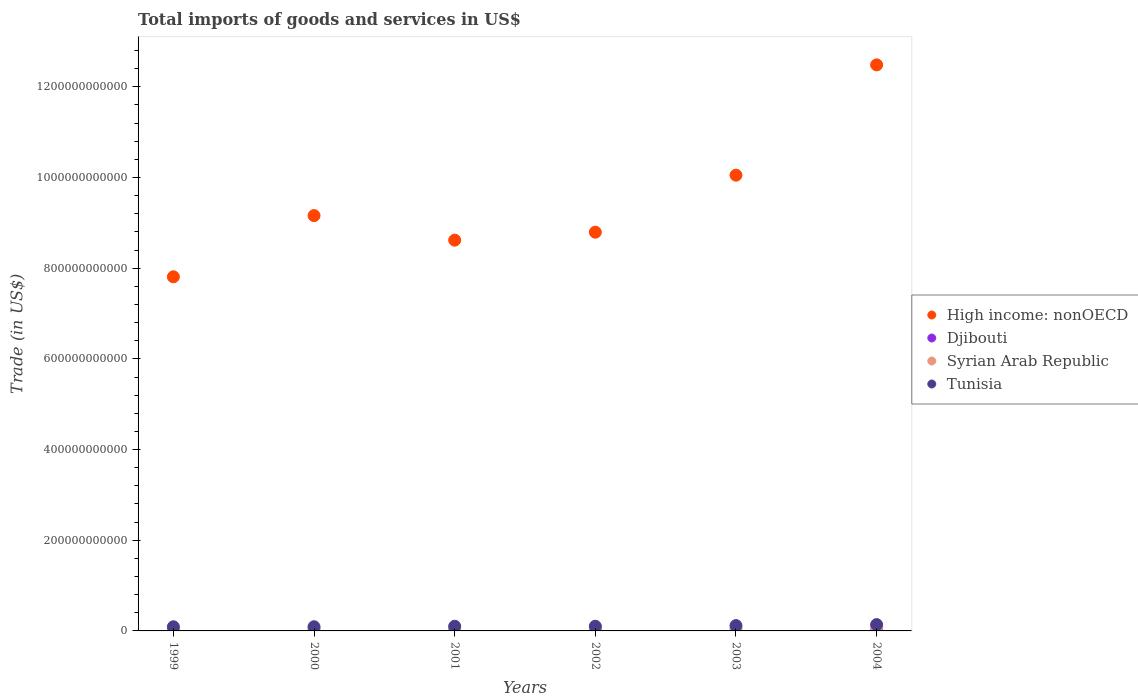What is the total imports of goods and services in High income: nonOECD in 2001?
Provide a short and direct response. 8.62e+11. Across all years, what is the maximum total imports of goods and services in Djibouti?
Keep it short and to the point. 3.61e+08. Across all years, what is the minimum total imports of goods and services in Syrian Arab Republic?
Your answer should be very brief. 5.08e+09. What is the total total imports of goods and services in Syrian Arab Republic in the graph?
Give a very brief answer. 3.96e+1. What is the difference between the total imports of goods and services in Djibouti in 1999 and that in 2002?
Keep it short and to the point. 6.13e+05. What is the difference between the total imports of goods and services in Syrian Arab Republic in 2002 and the total imports of goods and services in Tunisia in 2001?
Offer a very short reply. -3.72e+09. What is the average total imports of goods and services in Djibouti per year?
Give a very brief answer. 2.87e+08. In the year 2000, what is the difference between the total imports of goods and services in Syrian Arab Republic and total imports of goods and services in Tunisia?
Provide a succinct answer. -3.69e+09. In how many years, is the total imports of goods and services in Tunisia greater than 480000000000 US$?
Provide a succinct answer. 0. What is the ratio of the total imports of goods and services in High income: nonOECD in 1999 to that in 2000?
Your response must be concise. 0.85. Is the difference between the total imports of goods and services in Syrian Arab Republic in 2002 and 2004 greater than the difference between the total imports of goods and services in Tunisia in 2002 and 2004?
Your response must be concise. Yes. What is the difference between the highest and the second highest total imports of goods and services in Syrian Arab Republic?
Offer a very short reply. 3.40e+09. What is the difference between the highest and the lowest total imports of goods and services in High income: nonOECD?
Keep it short and to the point. 4.67e+11. Is the sum of the total imports of goods and services in Syrian Arab Republic in 2000 and 2003 greater than the maximum total imports of goods and services in High income: nonOECD across all years?
Provide a short and direct response. No. Is it the case that in every year, the sum of the total imports of goods and services in High income: nonOECD and total imports of goods and services in Djibouti  is greater than the sum of total imports of goods and services in Tunisia and total imports of goods and services in Syrian Arab Republic?
Provide a short and direct response. Yes. Is it the case that in every year, the sum of the total imports of goods and services in High income: nonOECD and total imports of goods and services in Tunisia  is greater than the total imports of goods and services in Syrian Arab Republic?
Give a very brief answer. Yes. Does the total imports of goods and services in Syrian Arab Republic monotonically increase over the years?
Provide a succinct answer. No. Is the total imports of goods and services in Tunisia strictly less than the total imports of goods and services in Djibouti over the years?
Provide a succinct answer. No. How many years are there in the graph?
Provide a short and direct response. 6. What is the difference between two consecutive major ticks on the Y-axis?
Ensure brevity in your answer.  2.00e+11. Does the graph contain any zero values?
Offer a very short reply. No. Does the graph contain grids?
Give a very brief answer. No. Where does the legend appear in the graph?
Offer a very short reply. Center right. How are the legend labels stacked?
Provide a succinct answer. Vertical. What is the title of the graph?
Your answer should be compact. Total imports of goods and services in US$. Does "Honduras" appear as one of the legend labels in the graph?
Your answer should be very brief. No. What is the label or title of the X-axis?
Your answer should be compact. Years. What is the label or title of the Y-axis?
Your answer should be compact. Trade (in US$). What is the Trade (in US$) in High income: nonOECD in 1999?
Make the answer very short. 7.81e+11. What is the Trade (in US$) of Djibouti in 1999?
Make the answer very short. 2.59e+08. What is the Trade (in US$) of Syrian Arab Republic in 1999?
Provide a short and direct response. 5.08e+09. What is the Trade (in US$) of Tunisia in 1999?
Make the answer very short. 9.16e+09. What is the Trade (in US$) in High income: nonOECD in 2000?
Ensure brevity in your answer.  9.16e+11. What is the Trade (in US$) in Djibouti in 2000?
Ensure brevity in your answer.  2.78e+08. What is the Trade (in US$) of Syrian Arab Republic in 2000?
Offer a terse response. 5.52e+09. What is the Trade (in US$) of Tunisia in 2000?
Give a very brief answer. 9.21e+09. What is the Trade (in US$) in High income: nonOECD in 2001?
Provide a succinct answer. 8.62e+11. What is the Trade (in US$) in Djibouti in 2001?
Ensure brevity in your answer.  2.62e+08. What is the Trade (in US$) in Syrian Arab Republic in 2001?
Ensure brevity in your answer.  6.17e+09. What is the Trade (in US$) in Tunisia in 2001?
Make the answer very short. 1.03e+1. What is the Trade (in US$) in High income: nonOECD in 2002?
Your answer should be very brief. 8.79e+11. What is the Trade (in US$) in Djibouti in 2002?
Make the answer very short. 2.59e+08. What is the Trade (in US$) in Syrian Arab Republic in 2002?
Offer a very short reply. 6.59e+09. What is the Trade (in US$) of Tunisia in 2002?
Your response must be concise. 1.03e+1. What is the Trade (in US$) in High income: nonOECD in 2003?
Your response must be concise. 1.01e+12. What is the Trade (in US$) in Djibouti in 2003?
Your answer should be compact. 3.05e+08. What is the Trade (in US$) in Syrian Arab Republic in 2003?
Offer a very short reply. 6.24e+09. What is the Trade (in US$) of Tunisia in 2003?
Provide a short and direct response. 1.18e+1. What is the Trade (in US$) in High income: nonOECD in 2004?
Make the answer very short. 1.25e+12. What is the Trade (in US$) of Djibouti in 2004?
Offer a very short reply. 3.61e+08. What is the Trade (in US$) in Syrian Arab Republic in 2004?
Provide a short and direct response. 9.99e+09. What is the Trade (in US$) of Tunisia in 2004?
Provide a short and direct response. 1.39e+1. Across all years, what is the maximum Trade (in US$) in High income: nonOECD?
Offer a very short reply. 1.25e+12. Across all years, what is the maximum Trade (in US$) in Djibouti?
Provide a short and direct response. 3.61e+08. Across all years, what is the maximum Trade (in US$) in Syrian Arab Republic?
Offer a terse response. 9.99e+09. Across all years, what is the maximum Trade (in US$) in Tunisia?
Make the answer very short. 1.39e+1. Across all years, what is the minimum Trade (in US$) of High income: nonOECD?
Provide a succinct answer. 7.81e+11. Across all years, what is the minimum Trade (in US$) of Djibouti?
Your answer should be very brief. 2.59e+08. Across all years, what is the minimum Trade (in US$) in Syrian Arab Republic?
Ensure brevity in your answer.  5.08e+09. Across all years, what is the minimum Trade (in US$) of Tunisia?
Offer a terse response. 9.16e+09. What is the total Trade (in US$) in High income: nonOECD in the graph?
Give a very brief answer. 5.69e+12. What is the total Trade (in US$) of Djibouti in the graph?
Provide a succinct answer. 1.72e+09. What is the total Trade (in US$) in Syrian Arab Republic in the graph?
Ensure brevity in your answer.  3.96e+1. What is the total Trade (in US$) in Tunisia in the graph?
Offer a terse response. 6.47e+1. What is the difference between the Trade (in US$) of High income: nonOECD in 1999 and that in 2000?
Give a very brief answer. -1.35e+11. What is the difference between the Trade (in US$) of Djibouti in 1999 and that in 2000?
Make the answer very short. -1.85e+07. What is the difference between the Trade (in US$) of Syrian Arab Republic in 1999 and that in 2000?
Provide a short and direct response. -4.45e+08. What is the difference between the Trade (in US$) in Tunisia in 1999 and that in 2000?
Your response must be concise. -5.35e+07. What is the difference between the Trade (in US$) of High income: nonOECD in 1999 and that in 2001?
Provide a succinct answer. -8.08e+1. What is the difference between the Trade (in US$) in Djibouti in 1999 and that in 2001?
Your answer should be very brief. -2.78e+06. What is the difference between the Trade (in US$) of Syrian Arab Republic in 1999 and that in 2001?
Give a very brief answer. -1.09e+09. What is the difference between the Trade (in US$) in Tunisia in 1999 and that in 2001?
Your answer should be compact. -1.15e+09. What is the difference between the Trade (in US$) of High income: nonOECD in 1999 and that in 2002?
Make the answer very short. -9.84e+1. What is the difference between the Trade (in US$) of Djibouti in 1999 and that in 2002?
Ensure brevity in your answer.  6.13e+05. What is the difference between the Trade (in US$) in Syrian Arab Republic in 1999 and that in 2002?
Give a very brief answer. -1.51e+09. What is the difference between the Trade (in US$) of Tunisia in 1999 and that in 2002?
Keep it short and to the point. -1.15e+09. What is the difference between the Trade (in US$) in High income: nonOECD in 1999 and that in 2003?
Keep it short and to the point. -2.24e+11. What is the difference between the Trade (in US$) of Djibouti in 1999 and that in 2003?
Keep it short and to the point. -4.60e+07. What is the difference between the Trade (in US$) in Syrian Arab Republic in 1999 and that in 2003?
Make the answer very short. -1.16e+09. What is the difference between the Trade (in US$) in Tunisia in 1999 and that in 2003?
Offer a terse response. -2.62e+09. What is the difference between the Trade (in US$) of High income: nonOECD in 1999 and that in 2004?
Give a very brief answer. -4.67e+11. What is the difference between the Trade (in US$) in Djibouti in 1999 and that in 2004?
Provide a short and direct response. -1.02e+08. What is the difference between the Trade (in US$) in Syrian Arab Republic in 1999 and that in 2004?
Your response must be concise. -4.91e+09. What is the difference between the Trade (in US$) in Tunisia in 1999 and that in 2004?
Your response must be concise. -4.79e+09. What is the difference between the Trade (in US$) in High income: nonOECD in 2000 and that in 2001?
Give a very brief answer. 5.42e+1. What is the difference between the Trade (in US$) in Djibouti in 2000 and that in 2001?
Your response must be concise. 1.57e+07. What is the difference between the Trade (in US$) in Syrian Arab Republic in 2000 and that in 2001?
Your answer should be very brief. -6.45e+08. What is the difference between the Trade (in US$) in Tunisia in 2000 and that in 2001?
Provide a succinct answer. -1.10e+09. What is the difference between the Trade (in US$) in High income: nonOECD in 2000 and that in 2002?
Keep it short and to the point. 3.66e+1. What is the difference between the Trade (in US$) in Djibouti in 2000 and that in 2002?
Offer a terse response. 1.91e+07. What is the difference between the Trade (in US$) of Syrian Arab Republic in 2000 and that in 2002?
Your answer should be very brief. -1.07e+09. What is the difference between the Trade (in US$) in Tunisia in 2000 and that in 2002?
Your response must be concise. -1.10e+09. What is the difference between the Trade (in US$) of High income: nonOECD in 2000 and that in 2003?
Offer a terse response. -8.91e+1. What is the difference between the Trade (in US$) in Djibouti in 2000 and that in 2003?
Give a very brief answer. -2.75e+07. What is the difference between the Trade (in US$) in Syrian Arab Republic in 2000 and that in 2003?
Provide a succinct answer. -7.12e+08. What is the difference between the Trade (in US$) of Tunisia in 2000 and that in 2003?
Provide a succinct answer. -2.57e+09. What is the difference between the Trade (in US$) in High income: nonOECD in 2000 and that in 2004?
Provide a short and direct response. -3.32e+11. What is the difference between the Trade (in US$) of Djibouti in 2000 and that in 2004?
Make the answer very short. -8.31e+07. What is the difference between the Trade (in US$) of Syrian Arab Republic in 2000 and that in 2004?
Ensure brevity in your answer.  -4.46e+09. What is the difference between the Trade (in US$) in Tunisia in 2000 and that in 2004?
Your answer should be very brief. -4.73e+09. What is the difference between the Trade (in US$) in High income: nonOECD in 2001 and that in 2002?
Offer a terse response. -1.76e+1. What is the difference between the Trade (in US$) in Djibouti in 2001 and that in 2002?
Keep it short and to the point. 3.39e+06. What is the difference between the Trade (in US$) of Syrian Arab Republic in 2001 and that in 2002?
Give a very brief answer. -4.23e+08. What is the difference between the Trade (in US$) of Tunisia in 2001 and that in 2002?
Provide a short and direct response. 1.11e+06. What is the difference between the Trade (in US$) of High income: nonOECD in 2001 and that in 2003?
Your answer should be very brief. -1.43e+11. What is the difference between the Trade (in US$) of Djibouti in 2001 and that in 2003?
Provide a succinct answer. -4.32e+07. What is the difference between the Trade (in US$) of Syrian Arab Republic in 2001 and that in 2003?
Ensure brevity in your answer.  -6.74e+07. What is the difference between the Trade (in US$) of Tunisia in 2001 and that in 2003?
Provide a succinct answer. -1.47e+09. What is the difference between the Trade (in US$) in High income: nonOECD in 2001 and that in 2004?
Offer a very short reply. -3.87e+11. What is the difference between the Trade (in US$) in Djibouti in 2001 and that in 2004?
Give a very brief answer. -9.88e+07. What is the difference between the Trade (in US$) in Syrian Arab Republic in 2001 and that in 2004?
Make the answer very short. -3.82e+09. What is the difference between the Trade (in US$) of Tunisia in 2001 and that in 2004?
Offer a very short reply. -3.63e+09. What is the difference between the Trade (in US$) in High income: nonOECD in 2002 and that in 2003?
Make the answer very short. -1.26e+11. What is the difference between the Trade (in US$) in Djibouti in 2002 and that in 2003?
Keep it short and to the point. -4.66e+07. What is the difference between the Trade (in US$) of Syrian Arab Republic in 2002 and that in 2003?
Provide a short and direct response. 3.56e+08. What is the difference between the Trade (in US$) of Tunisia in 2002 and that in 2003?
Your answer should be compact. -1.47e+09. What is the difference between the Trade (in US$) in High income: nonOECD in 2002 and that in 2004?
Your response must be concise. -3.69e+11. What is the difference between the Trade (in US$) of Djibouti in 2002 and that in 2004?
Provide a short and direct response. -1.02e+08. What is the difference between the Trade (in US$) of Syrian Arab Republic in 2002 and that in 2004?
Ensure brevity in your answer.  -3.40e+09. What is the difference between the Trade (in US$) of Tunisia in 2002 and that in 2004?
Offer a terse response. -3.64e+09. What is the difference between the Trade (in US$) in High income: nonOECD in 2003 and that in 2004?
Your answer should be very brief. -2.43e+11. What is the difference between the Trade (in US$) of Djibouti in 2003 and that in 2004?
Ensure brevity in your answer.  -5.56e+07. What is the difference between the Trade (in US$) in Syrian Arab Republic in 2003 and that in 2004?
Provide a succinct answer. -3.75e+09. What is the difference between the Trade (in US$) of Tunisia in 2003 and that in 2004?
Give a very brief answer. -2.17e+09. What is the difference between the Trade (in US$) of High income: nonOECD in 1999 and the Trade (in US$) of Djibouti in 2000?
Provide a succinct answer. 7.81e+11. What is the difference between the Trade (in US$) of High income: nonOECD in 1999 and the Trade (in US$) of Syrian Arab Republic in 2000?
Offer a very short reply. 7.75e+11. What is the difference between the Trade (in US$) in High income: nonOECD in 1999 and the Trade (in US$) in Tunisia in 2000?
Your answer should be very brief. 7.72e+11. What is the difference between the Trade (in US$) of Djibouti in 1999 and the Trade (in US$) of Syrian Arab Republic in 2000?
Offer a very short reply. -5.26e+09. What is the difference between the Trade (in US$) of Djibouti in 1999 and the Trade (in US$) of Tunisia in 2000?
Provide a succinct answer. -8.95e+09. What is the difference between the Trade (in US$) in Syrian Arab Republic in 1999 and the Trade (in US$) in Tunisia in 2000?
Your response must be concise. -4.14e+09. What is the difference between the Trade (in US$) of High income: nonOECD in 1999 and the Trade (in US$) of Djibouti in 2001?
Give a very brief answer. 7.81e+11. What is the difference between the Trade (in US$) in High income: nonOECD in 1999 and the Trade (in US$) in Syrian Arab Republic in 2001?
Provide a succinct answer. 7.75e+11. What is the difference between the Trade (in US$) in High income: nonOECD in 1999 and the Trade (in US$) in Tunisia in 2001?
Your answer should be very brief. 7.71e+11. What is the difference between the Trade (in US$) of Djibouti in 1999 and the Trade (in US$) of Syrian Arab Republic in 2001?
Provide a short and direct response. -5.91e+09. What is the difference between the Trade (in US$) of Djibouti in 1999 and the Trade (in US$) of Tunisia in 2001?
Your response must be concise. -1.01e+1. What is the difference between the Trade (in US$) of Syrian Arab Republic in 1999 and the Trade (in US$) of Tunisia in 2001?
Provide a short and direct response. -5.23e+09. What is the difference between the Trade (in US$) of High income: nonOECD in 1999 and the Trade (in US$) of Djibouti in 2002?
Provide a succinct answer. 7.81e+11. What is the difference between the Trade (in US$) of High income: nonOECD in 1999 and the Trade (in US$) of Syrian Arab Republic in 2002?
Offer a terse response. 7.74e+11. What is the difference between the Trade (in US$) of High income: nonOECD in 1999 and the Trade (in US$) of Tunisia in 2002?
Provide a short and direct response. 7.71e+11. What is the difference between the Trade (in US$) of Djibouti in 1999 and the Trade (in US$) of Syrian Arab Republic in 2002?
Provide a short and direct response. -6.33e+09. What is the difference between the Trade (in US$) of Djibouti in 1999 and the Trade (in US$) of Tunisia in 2002?
Your response must be concise. -1.01e+1. What is the difference between the Trade (in US$) in Syrian Arab Republic in 1999 and the Trade (in US$) in Tunisia in 2002?
Give a very brief answer. -5.23e+09. What is the difference between the Trade (in US$) in High income: nonOECD in 1999 and the Trade (in US$) in Djibouti in 2003?
Offer a terse response. 7.81e+11. What is the difference between the Trade (in US$) of High income: nonOECD in 1999 and the Trade (in US$) of Syrian Arab Republic in 2003?
Provide a succinct answer. 7.75e+11. What is the difference between the Trade (in US$) of High income: nonOECD in 1999 and the Trade (in US$) of Tunisia in 2003?
Offer a terse response. 7.69e+11. What is the difference between the Trade (in US$) in Djibouti in 1999 and the Trade (in US$) in Syrian Arab Republic in 2003?
Offer a very short reply. -5.98e+09. What is the difference between the Trade (in US$) of Djibouti in 1999 and the Trade (in US$) of Tunisia in 2003?
Your answer should be compact. -1.15e+1. What is the difference between the Trade (in US$) in Syrian Arab Republic in 1999 and the Trade (in US$) in Tunisia in 2003?
Offer a terse response. -6.70e+09. What is the difference between the Trade (in US$) in High income: nonOECD in 1999 and the Trade (in US$) in Djibouti in 2004?
Your answer should be very brief. 7.81e+11. What is the difference between the Trade (in US$) in High income: nonOECD in 1999 and the Trade (in US$) in Syrian Arab Republic in 2004?
Offer a terse response. 7.71e+11. What is the difference between the Trade (in US$) of High income: nonOECD in 1999 and the Trade (in US$) of Tunisia in 2004?
Offer a very short reply. 7.67e+11. What is the difference between the Trade (in US$) of Djibouti in 1999 and the Trade (in US$) of Syrian Arab Republic in 2004?
Make the answer very short. -9.73e+09. What is the difference between the Trade (in US$) of Djibouti in 1999 and the Trade (in US$) of Tunisia in 2004?
Provide a succinct answer. -1.37e+1. What is the difference between the Trade (in US$) in Syrian Arab Republic in 1999 and the Trade (in US$) in Tunisia in 2004?
Make the answer very short. -8.87e+09. What is the difference between the Trade (in US$) in High income: nonOECD in 2000 and the Trade (in US$) in Djibouti in 2001?
Your response must be concise. 9.16e+11. What is the difference between the Trade (in US$) of High income: nonOECD in 2000 and the Trade (in US$) of Syrian Arab Republic in 2001?
Offer a terse response. 9.10e+11. What is the difference between the Trade (in US$) of High income: nonOECD in 2000 and the Trade (in US$) of Tunisia in 2001?
Ensure brevity in your answer.  9.06e+11. What is the difference between the Trade (in US$) in Djibouti in 2000 and the Trade (in US$) in Syrian Arab Republic in 2001?
Provide a succinct answer. -5.89e+09. What is the difference between the Trade (in US$) in Djibouti in 2000 and the Trade (in US$) in Tunisia in 2001?
Your response must be concise. -1.00e+1. What is the difference between the Trade (in US$) in Syrian Arab Republic in 2000 and the Trade (in US$) in Tunisia in 2001?
Provide a succinct answer. -4.79e+09. What is the difference between the Trade (in US$) of High income: nonOECD in 2000 and the Trade (in US$) of Djibouti in 2002?
Ensure brevity in your answer.  9.16e+11. What is the difference between the Trade (in US$) of High income: nonOECD in 2000 and the Trade (in US$) of Syrian Arab Republic in 2002?
Make the answer very short. 9.09e+11. What is the difference between the Trade (in US$) of High income: nonOECD in 2000 and the Trade (in US$) of Tunisia in 2002?
Your answer should be very brief. 9.06e+11. What is the difference between the Trade (in US$) of Djibouti in 2000 and the Trade (in US$) of Syrian Arab Republic in 2002?
Your answer should be very brief. -6.31e+09. What is the difference between the Trade (in US$) of Djibouti in 2000 and the Trade (in US$) of Tunisia in 2002?
Give a very brief answer. -1.00e+1. What is the difference between the Trade (in US$) of Syrian Arab Republic in 2000 and the Trade (in US$) of Tunisia in 2002?
Offer a terse response. -4.79e+09. What is the difference between the Trade (in US$) in High income: nonOECD in 2000 and the Trade (in US$) in Djibouti in 2003?
Ensure brevity in your answer.  9.16e+11. What is the difference between the Trade (in US$) in High income: nonOECD in 2000 and the Trade (in US$) in Syrian Arab Republic in 2003?
Give a very brief answer. 9.10e+11. What is the difference between the Trade (in US$) in High income: nonOECD in 2000 and the Trade (in US$) in Tunisia in 2003?
Your answer should be compact. 9.04e+11. What is the difference between the Trade (in US$) in Djibouti in 2000 and the Trade (in US$) in Syrian Arab Republic in 2003?
Your response must be concise. -5.96e+09. What is the difference between the Trade (in US$) in Djibouti in 2000 and the Trade (in US$) in Tunisia in 2003?
Offer a terse response. -1.15e+1. What is the difference between the Trade (in US$) in Syrian Arab Republic in 2000 and the Trade (in US$) in Tunisia in 2003?
Provide a succinct answer. -6.26e+09. What is the difference between the Trade (in US$) of High income: nonOECD in 2000 and the Trade (in US$) of Djibouti in 2004?
Offer a terse response. 9.16e+11. What is the difference between the Trade (in US$) in High income: nonOECD in 2000 and the Trade (in US$) in Syrian Arab Republic in 2004?
Make the answer very short. 9.06e+11. What is the difference between the Trade (in US$) of High income: nonOECD in 2000 and the Trade (in US$) of Tunisia in 2004?
Make the answer very short. 9.02e+11. What is the difference between the Trade (in US$) of Djibouti in 2000 and the Trade (in US$) of Syrian Arab Republic in 2004?
Keep it short and to the point. -9.71e+09. What is the difference between the Trade (in US$) in Djibouti in 2000 and the Trade (in US$) in Tunisia in 2004?
Offer a very short reply. -1.37e+1. What is the difference between the Trade (in US$) in Syrian Arab Republic in 2000 and the Trade (in US$) in Tunisia in 2004?
Ensure brevity in your answer.  -8.42e+09. What is the difference between the Trade (in US$) in High income: nonOECD in 2001 and the Trade (in US$) in Djibouti in 2002?
Keep it short and to the point. 8.62e+11. What is the difference between the Trade (in US$) of High income: nonOECD in 2001 and the Trade (in US$) of Syrian Arab Republic in 2002?
Make the answer very short. 8.55e+11. What is the difference between the Trade (in US$) in High income: nonOECD in 2001 and the Trade (in US$) in Tunisia in 2002?
Provide a succinct answer. 8.51e+11. What is the difference between the Trade (in US$) of Djibouti in 2001 and the Trade (in US$) of Syrian Arab Republic in 2002?
Keep it short and to the point. -6.33e+09. What is the difference between the Trade (in US$) in Djibouti in 2001 and the Trade (in US$) in Tunisia in 2002?
Provide a succinct answer. -1.00e+1. What is the difference between the Trade (in US$) of Syrian Arab Republic in 2001 and the Trade (in US$) of Tunisia in 2002?
Ensure brevity in your answer.  -4.14e+09. What is the difference between the Trade (in US$) in High income: nonOECD in 2001 and the Trade (in US$) in Djibouti in 2003?
Keep it short and to the point. 8.61e+11. What is the difference between the Trade (in US$) of High income: nonOECD in 2001 and the Trade (in US$) of Syrian Arab Republic in 2003?
Provide a succinct answer. 8.56e+11. What is the difference between the Trade (in US$) in High income: nonOECD in 2001 and the Trade (in US$) in Tunisia in 2003?
Ensure brevity in your answer.  8.50e+11. What is the difference between the Trade (in US$) of Djibouti in 2001 and the Trade (in US$) of Syrian Arab Republic in 2003?
Give a very brief answer. -5.97e+09. What is the difference between the Trade (in US$) of Djibouti in 2001 and the Trade (in US$) of Tunisia in 2003?
Make the answer very short. -1.15e+1. What is the difference between the Trade (in US$) in Syrian Arab Republic in 2001 and the Trade (in US$) in Tunisia in 2003?
Offer a very short reply. -5.61e+09. What is the difference between the Trade (in US$) of High income: nonOECD in 2001 and the Trade (in US$) of Djibouti in 2004?
Your answer should be compact. 8.61e+11. What is the difference between the Trade (in US$) in High income: nonOECD in 2001 and the Trade (in US$) in Syrian Arab Republic in 2004?
Your response must be concise. 8.52e+11. What is the difference between the Trade (in US$) of High income: nonOECD in 2001 and the Trade (in US$) of Tunisia in 2004?
Ensure brevity in your answer.  8.48e+11. What is the difference between the Trade (in US$) in Djibouti in 2001 and the Trade (in US$) in Syrian Arab Republic in 2004?
Provide a short and direct response. -9.73e+09. What is the difference between the Trade (in US$) of Djibouti in 2001 and the Trade (in US$) of Tunisia in 2004?
Keep it short and to the point. -1.37e+1. What is the difference between the Trade (in US$) of Syrian Arab Republic in 2001 and the Trade (in US$) of Tunisia in 2004?
Provide a short and direct response. -7.78e+09. What is the difference between the Trade (in US$) in High income: nonOECD in 2002 and the Trade (in US$) in Djibouti in 2003?
Provide a succinct answer. 8.79e+11. What is the difference between the Trade (in US$) in High income: nonOECD in 2002 and the Trade (in US$) in Syrian Arab Republic in 2003?
Keep it short and to the point. 8.73e+11. What is the difference between the Trade (in US$) of High income: nonOECD in 2002 and the Trade (in US$) of Tunisia in 2003?
Make the answer very short. 8.68e+11. What is the difference between the Trade (in US$) of Djibouti in 2002 and the Trade (in US$) of Syrian Arab Republic in 2003?
Make the answer very short. -5.98e+09. What is the difference between the Trade (in US$) of Djibouti in 2002 and the Trade (in US$) of Tunisia in 2003?
Make the answer very short. -1.15e+1. What is the difference between the Trade (in US$) of Syrian Arab Republic in 2002 and the Trade (in US$) of Tunisia in 2003?
Offer a terse response. -5.19e+09. What is the difference between the Trade (in US$) in High income: nonOECD in 2002 and the Trade (in US$) in Djibouti in 2004?
Your answer should be compact. 8.79e+11. What is the difference between the Trade (in US$) in High income: nonOECD in 2002 and the Trade (in US$) in Syrian Arab Republic in 2004?
Your answer should be very brief. 8.69e+11. What is the difference between the Trade (in US$) in High income: nonOECD in 2002 and the Trade (in US$) in Tunisia in 2004?
Ensure brevity in your answer.  8.65e+11. What is the difference between the Trade (in US$) of Djibouti in 2002 and the Trade (in US$) of Syrian Arab Republic in 2004?
Keep it short and to the point. -9.73e+09. What is the difference between the Trade (in US$) of Djibouti in 2002 and the Trade (in US$) of Tunisia in 2004?
Your response must be concise. -1.37e+1. What is the difference between the Trade (in US$) of Syrian Arab Republic in 2002 and the Trade (in US$) of Tunisia in 2004?
Make the answer very short. -7.36e+09. What is the difference between the Trade (in US$) in High income: nonOECD in 2003 and the Trade (in US$) in Djibouti in 2004?
Your answer should be compact. 1.00e+12. What is the difference between the Trade (in US$) in High income: nonOECD in 2003 and the Trade (in US$) in Syrian Arab Republic in 2004?
Your response must be concise. 9.95e+11. What is the difference between the Trade (in US$) of High income: nonOECD in 2003 and the Trade (in US$) of Tunisia in 2004?
Give a very brief answer. 9.91e+11. What is the difference between the Trade (in US$) in Djibouti in 2003 and the Trade (in US$) in Syrian Arab Republic in 2004?
Ensure brevity in your answer.  -9.68e+09. What is the difference between the Trade (in US$) of Djibouti in 2003 and the Trade (in US$) of Tunisia in 2004?
Keep it short and to the point. -1.36e+1. What is the difference between the Trade (in US$) of Syrian Arab Republic in 2003 and the Trade (in US$) of Tunisia in 2004?
Keep it short and to the point. -7.71e+09. What is the average Trade (in US$) of High income: nonOECD per year?
Ensure brevity in your answer.  9.49e+11. What is the average Trade (in US$) of Djibouti per year?
Your answer should be compact. 2.87e+08. What is the average Trade (in US$) of Syrian Arab Republic per year?
Provide a short and direct response. 6.60e+09. What is the average Trade (in US$) in Tunisia per year?
Offer a very short reply. 1.08e+1. In the year 1999, what is the difference between the Trade (in US$) in High income: nonOECD and Trade (in US$) in Djibouti?
Give a very brief answer. 7.81e+11. In the year 1999, what is the difference between the Trade (in US$) of High income: nonOECD and Trade (in US$) of Syrian Arab Republic?
Offer a terse response. 7.76e+11. In the year 1999, what is the difference between the Trade (in US$) of High income: nonOECD and Trade (in US$) of Tunisia?
Give a very brief answer. 7.72e+11. In the year 1999, what is the difference between the Trade (in US$) in Djibouti and Trade (in US$) in Syrian Arab Republic?
Your answer should be very brief. -4.82e+09. In the year 1999, what is the difference between the Trade (in US$) of Djibouti and Trade (in US$) of Tunisia?
Your answer should be compact. -8.90e+09. In the year 1999, what is the difference between the Trade (in US$) of Syrian Arab Republic and Trade (in US$) of Tunisia?
Offer a terse response. -4.08e+09. In the year 2000, what is the difference between the Trade (in US$) in High income: nonOECD and Trade (in US$) in Djibouti?
Offer a very short reply. 9.16e+11. In the year 2000, what is the difference between the Trade (in US$) in High income: nonOECD and Trade (in US$) in Syrian Arab Republic?
Your answer should be very brief. 9.10e+11. In the year 2000, what is the difference between the Trade (in US$) in High income: nonOECD and Trade (in US$) in Tunisia?
Keep it short and to the point. 9.07e+11. In the year 2000, what is the difference between the Trade (in US$) of Djibouti and Trade (in US$) of Syrian Arab Republic?
Offer a very short reply. -5.25e+09. In the year 2000, what is the difference between the Trade (in US$) of Djibouti and Trade (in US$) of Tunisia?
Offer a terse response. -8.94e+09. In the year 2000, what is the difference between the Trade (in US$) in Syrian Arab Republic and Trade (in US$) in Tunisia?
Offer a terse response. -3.69e+09. In the year 2001, what is the difference between the Trade (in US$) of High income: nonOECD and Trade (in US$) of Djibouti?
Provide a short and direct response. 8.62e+11. In the year 2001, what is the difference between the Trade (in US$) of High income: nonOECD and Trade (in US$) of Syrian Arab Republic?
Give a very brief answer. 8.56e+11. In the year 2001, what is the difference between the Trade (in US$) of High income: nonOECD and Trade (in US$) of Tunisia?
Ensure brevity in your answer.  8.51e+11. In the year 2001, what is the difference between the Trade (in US$) in Djibouti and Trade (in US$) in Syrian Arab Republic?
Your answer should be very brief. -5.91e+09. In the year 2001, what is the difference between the Trade (in US$) in Djibouti and Trade (in US$) in Tunisia?
Your answer should be very brief. -1.01e+1. In the year 2001, what is the difference between the Trade (in US$) in Syrian Arab Republic and Trade (in US$) in Tunisia?
Offer a very short reply. -4.14e+09. In the year 2002, what is the difference between the Trade (in US$) in High income: nonOECD and Trade (in US$) in Djibouti?
Make the answer very short. 8.79e+11. In the year 2002, what is the difference between the Trade (in US$) in High income: nonOECD and Trade (in US$) in Syrian Arab Republic?
Provide a short and direct response. 8.73e+11. In the year 2002, what is the difference between the Trade (in US$) of High income: nonOECD and Trade (in US$) of Tunisia?
Offer a very short reply. 8.69e+11. In the year 2002, what is the difference between the Trade (in US$) in Djibouti and Trade (in US$) in Syrian Arab Republic?
Your answer should be compact. -6.33e+09. In the year 2002, what is the difference between the Trade (in US$) in Djibouti and Trade (in US$) in Tunisia?
Your answer should be very brief. -1.01e+1. In the year 2002, what is the difference between the Trade (in US$) of Syrian Arab Republic and Trade (in US$) of Tunisia?
Your answer should be compact. -3.72e+09. In the year 2003, what is the difference between the Trade (in US$) in High income: nonOECD and Trade (in US$) in Djibouti?
Provide a short and direct response. 1.00e+12. In the year 2003, what is the difference between the Trade (in US$) in High income: nonOECD and Trade (in US$) in Syrian Arab Republic?
Your answer should be compact. 9.99e+11. In the year 2003, what is the difference between the Trade (in US$) of High income: nonOECD and Trade (in US$) of Tunisia?
Give a very brief answer. 9.93e+11. In the year 2003, what is the difference between the Trade (in US$) in Djibouti and Trade (in US$) in Syrian Arab Republic?
Your answer should be compact. -5.93e+09. In the year 2003, what is the difference between the Trade (in US$) of Djibouti and Trade (in US$) of Tunisia?
Provide a succinct answer. -1.15e+1. In the year 2003, what is the difference between the Trade (in US$) of Syrian Arab Republic and Trade (in US$) of Tunisia?
Ensure brevity in your answer.  -5.54e+09. In the year 2004, what is the difference between the Trade (in US$) of High income: nonOECD and Trade (in US$) of Djibouti?
Provide a succinct answer. 1.25e+12. In the year 2004, what is the difference between the Trade (in US$) in High income: nonOECD and Trade (in US$) in Syrian Arab Republic?
Offer a terse response. 1.24e+12. In the year 2004, what is the difference between the Trade (in US$) in High income: nonOECD and Trade (in US$) in Tunisia?
Your response must be concise. 1.23e+12. In the year 2004, what is the difference between the Trade (in US$) in Djibouti and Trade (in US$) in Syrian Arab Republic?
Give a very brief answer. -9.63e+09. In the year 2004, what is the difference between the Trade (in US$) of Djibouti and Trade (in US$) of Tunisia?
Keep it short and to the point. -1.36e+1. In the year 2004, what is the difference between the Trade (in US$) of Syrian Arab Republic and Trade (in US$) of Tunisia?
Give a very brief answer. -3.96e+09. What is the ratio of the Trade (in US$) of High income: nonOECD in 1999 to that in 2000?
Provide a short and direct response. 0.85. What is the ratio of the Trade (in US$) in Djibouti in 1999 to that in 2000?
Your answer should be very brief. 0.93. What is the ratio of the Trade (in US$) of Syrian Arab Republic in 1999 to that in 2000?
Your answer should be compact. 0.92. What is the ratio of the Trade (in US$) in High income: nonOECD in 1999 to that in 2001?
Keep it short and to the point. 0.91. What is the ratio of the Trade (in US$) in Syrian Arab Republic in 1999 to that in 2001?
Provide a succinct answer. 0.82. What is the ratio of the Trade (in US$) of Tunisia in 1999 to that in 2001?
Provide a short and direct response. 0.89. What is the ratio of the Trade (in US$) of High income: nonOECD in 1999 to that in 2002?
Provide a succinct answer. 0.89. What is the ratio of the Trade (in US$) in Syrian Arab Republic in 1999 to that in 2002?
Offer a very short reply. 0.77. What is the ratio of the Trade (in US$) of Tunisia in 1999 to that in 2002?
Provide a succinct answer. 0.89. What is the ratio of the Trade (in US$) of High income: nonOECD in 1999 to that in 2003?
Your response must be concise. 0.78. What is the ratio of the Trade (in US$) in Djibouti in 1999 to that in 2003?
Your answer should be very brief. 0.85. What is the ratio of the Trade (in US$) in Syrian Arab Republic in 1999 to that in 2003?
Your response must be concise. 0.81. What is the ratio of the Trade (in US$) of Tunisia in 1999 to that in 2003?
Offer a terse response. 0.78. What is the ratio of the Trade (in US$) in High income: nonOECD in 1999 to that in 2004?
Keep it short and to the point. 0.63. What is the ratio of the Trade (in US$) in Djibouti in 1999 to that in 2004?
Offer a very short reply. 0.72. What is the ratio of the Trade (in US$) of Syrian Arab Republic in 1999 to that in 2004?
Your answer should be very brief. 0.51. What is the ratio of the Trade (in US$) of Tunisia in 1999 to that in 2004?
Offer a very short reply. 0.66. What is the ratio of the Trade (in US$) in High income: nonOECD in 2000 to that in 2001?
Your response must be concise. 1.06. What is the ratio of the Trade (in US$) of Djibouti in 2000 to that in 2001?
Provide a short and direct response. 1.06. What is the ratio of the Trade (in US$) of Syrian Arab Republic in 2000 to that in 2001?
Offer a very short reply. 0.9. What is the ratio of the Trade (in US$) in Tunisia in 2000 to that in 2001?
Make the answer very short. 0.89. What is the ratio of the Trade (in US$) of High income: nonOECD in 2000 to that in 2002?
Your answer should be compact. 1.04. What is the ratio of the Trade (in US$) in Djibouti in 2000 to that in 2002?
Offer a terse response. 1.07. What is the ratio of the Trade (in US$) of Syrian Arab Republic in 2000 to that in 2002?
Provide a short and direct response. 0.84. What is the ratio of the Trade (in US$) in Tunisia in 2000 to that in 2002?
Offer a terse response. 0.89. What is the ratio of the Trade (in US$) of High income: nonOECD in 2000 to that in 2003?
Offer a terse response. 0.91. What is the ratio of the Trade (in US$) of Djibouti in 2000 to that in 2003?
Your answer should be compact. 0.91. What is the ratio of the Trade (in US$) in Syrian Arab Republic in 2000 to that in 2003?
Your answer should be compact. 0.89. What is the ratio of the Trade (in US$) in Tunisia in 2000 to that in 2003?
Provide a short and direct response. 0.78. What is the ratio of the Trade (in US$) in High income: nonOECD in 2000 to that in 2004?
Offer a very short reply. 0.73. What is the ratio of the Trade (in US$) of Djibouti in 2000 to that in 2004?
Make the answer very short. 0.77. What is the ratio of the Trade (in US$) in Syrian Arab Republic in 2000 to that in 2004?
Offer a terse response. 0.55. What is the ratio of the Trade (in US$) of Tunisia in 2000 to that in 2004?
Keep it short and to the point. 0.66. What is the ratio of the Trade (in US$) of Djibouti in 2001 to that in 2002?
Your answer should be compact. 1.01. What is the ratio of the Trade (in US$) in Syrian Arab Republic in 2001 to that in 2002?
Ensure brevity in your answer.  0.94. What is the ratio of the Trade (in US$) of High income: nonOECD in 2001 to that in 2003?
Your answer should be very brief. 0.86. What is the ratio of the Trade (in US$) in Djibouti in 2001 to that in 2003?
Ensure brevity in your answer.  0.86. What is the ratio of the Trade (in US$) in Tunisia in 2001 to that in 2003?
Give a very brief answer. 0.88. What is the ratio of the Trade (in US$) of High income: nonOECD in 2001 to that in 2004?
Your answer should be compact. 0.69. What is the ratio of the Trade (in US$) in Djibouti in 2001 to that in 2004?
Offer a terse response. 0.73. What is the ratio of the Trade (in US$) in Syrian Arab Republic in 2001 to that in 2004?
Provide a short and direct response. 0.62. What is the ratio of the Trade (in US$) of Tunisia in 2001 to that in 2004?
Keep it short and to the point. 0.74. What is the ratio of the Trade (in US$) of High income: nonOECD in 2002 to that in 2003?
Offer a very short reply. 0.87. What is the ratio of the Trade (in US$) of Djibouti in 2002 to that in 2003?
Make the answer very short. 0.85. What is the ratio of the Trade (in US$) in Syrian Arab Republic in 2002 to that in 2003?
Keep it short and to the point. 1.06. What is the ratio of the Trade (in US$) in Tunisia in 2002 to that in 2003?
Ensure brevity in your answer.  0.88. What is the ratio of the Trade (in US$) in High income: nonOECD in 2002 to that in 2004?
Provide a succinct answer. 0.7. What is the ratio of the Trade (in US$) in Djibouti in 2002 to that in 2004?
Keep it short and to the point. 0.72. What is the ratio of the Trade (in US$) of Syrian Arab Republic in 2002 to that in 2004?
Your answer should be compact. 0.66. What is the ratio of the Trade (in US$) of Tunisia in 2002 to that in 2004?
Give a very brief answer. 0.74. What is the ratio of the Trade (in US$) in High income: nonOECD in 2003 to that in 2004?
Provide a succinct answer. 0.81. What is the ratio of the Trade (in US$) in Djibouti in 2003 to that in 2004?
Your response must be concise. 0.85. What is the ratio of the Trade (in US$) in Syrian Arab Republic in 2003 to that in 2004?
Provide a succinct answer. 0.62. What is the ratio of the Trade (in US$) in Tunisia in 2003 to that in 2004?
Your answer should be compact. 0.84. What is the difference between the highest and the second highest Trade (in US$) of High income: nonOECD?
Ensure brevity in your answer.  2.43e+11. What is the difference between the highest and the second highest Trade (in US$) of Djibouti?
Offer a very short reply. 5.56e+07. What is the difference between the highest and the second highest Trade (in US$) in Syrian Arab Republic?
Your answer should be compact. 3.40e+09. What is the difference between the highest and the second highest Trade (in US$) in Tunisia?
Your response must be concise. 2.17e+09. What is the difference between the highest and the lowest Trade (in US$) in High income: nonOECD?
Provide a short and direct response. 4.67e+11. What is the difference between the highest and the lowest Trade (in US$) of Djibouti?
Keep it short and to the point. 1.02e+08. What is the difference between the highest and the lowest Trade (in US$) in Syrian Arab Republic?
Make the answer very short. 4.91e+09. What is the difference between the highest and the lowest Trade (in US$) in Tunisia?
Offer a terse response. 4.79e+09. 